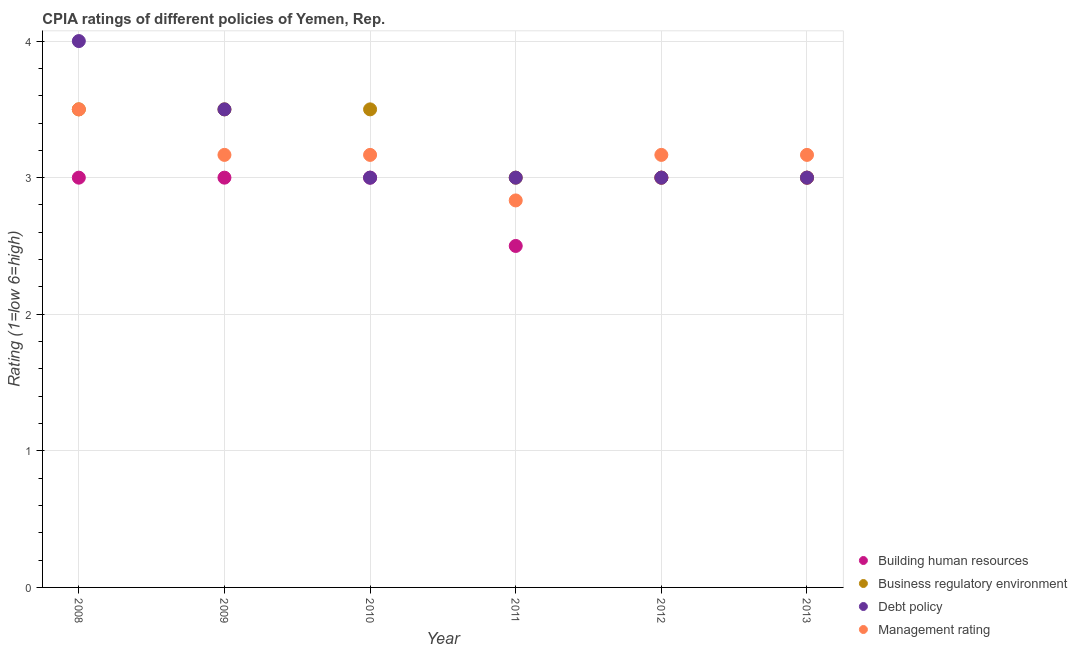In which year was the cpia rating of business regulatory environment maximum?
Your answer should be very brief. 2008. What is the difference between the cpia rating of debt policy in 2008 and the cpia rating of management in 2009?
Offer a very short reply. 0.83. What is the average cpia rating of building human resources per year?
Provide a succinct answer. 2.92. What is the ratio of the cpia rating of business regulatory environment in 2009 to that in 2011?
Give a very brief answer. 1.17. Is the difference between the cpia rating of building human resources in 2009 and 2011 greater than the difference between the cpia rating of management in 2009 and 2011?
Offer a terse response. Yes. What is the difference between the highest and the lowest cpia rating of building human resources?
Give a very brief answer. 0.5. In how many years, is the cpia rating of management greater than the average cpia rating of management taken over all years?
Keep it short and to the point. 5. Is the sum of the cpia rating of management in 2012 and 2013 greater than the maximum cpia rating of debt policy across all years?
Make the answer very short. Yes. Is it the case that in every year, the sum of the cpia rating of building human resources and cpia rating of business regulatory environment is greater than the cpia rating of debt policy?
Keep it short and to the point. Yes. Does the cpia rating of debt policy monotonically increase over the years?
Keep it short and to the point. No. Is the cpia rating of debt policy strictly greater than the cpia rating of management over the years?
Make the answer very short. No. Is the cpia rating of building human resources strictly less than the cpia rating of business regulatory environment over the years?
Offer a very short reply. No. How many years are there in the graph?
Keep it short and to the point. 6. What is the difference between two consecutive major ticks on the Y-axis?
Your response must be concise. 1. Where does the legend appear in the graph?
Make the answer very short. Bottom right. How many legend labels are there?
Your response must be concise. 4. How are the legend labels stacked?
Offer a very short reply. Vertical. What is the title of the graph?
Your response must be concise. CPIA ratings of different policies of Yemen, Rep. Does "Bird species" appear as one of the legend labels in the graph?
Offer a terse response. No. What is the label or title of the X-axis?
Keep it short and to the point. Year. What is the Rating (1=low 6=high) in Building human resources in 2008?
Your response must be concise. 3. What is the Rating (1=low 6=high) of Debt policy in 2008?
Your answer should be compact. 4. What is the Rating (1=low 6=high) in Management rating in 2008?
Your response must be concise. 3.5. What is the Rating (1=low 6=high) in Building human resources in 2009?
Make the answer very short. 3. What is the Rating (1=low 6=high) in Business regulatory environment in 2009?
Offer a very short reply. 3.5. What is the Rating (1=low 6=high) in Debt policy in 2009?
Provide a short and direct response. 3.5. What is the Rating (1=low 6=high) in Management rating in 2009?
Provide a succinct answer. 3.17. What is the Rating (1=low 6=high) in Business regulatory environment in 2010?
Provide a short and direct response. 3.5. What is the Rating (1=low 6=high) of Debt policy in 2010?
Your response must be concise. 3. What is the Rating (1=low 6=high) of Management rating in 2010?
Keep it short and to the point. 3.17. What is the Rating (1=low 6=high) of Business regulatory environment in 2011?
Your answer should be compact. 3. What is the Rating (1=low 6=high) of Debt policy in 2011?
Your answer should be compact. 3. What is the Rating (1=low 6=high) in Management rating in 2011?
Your answer should be very brief. 2.83. What is the Rating (1=low 6=high) of Debt policy in 2012?
Provide a short and direct response. 3. What is the Rating (1=low 6=high) in Management rating in 2012?
Provide a short and direct response. 3.17. What is the Rating (1=low 6=high) in Building human resources in 2013?
Keep it short and to the point. 3. What is the Rating (1=low 6=high) in Management rating in 2013?
Your answer should be very brief. 3.17. Across all years, what is the maximum Rating (1=low 6=high) of Building human resources?
Keep it short and to the point. 3. Across all years, what is the maximum Rating (1=low 6=high) of Management rating?
Provide a succinct answer. 3.5. Across all years, what is the minimum Rating (1=low 6=high) of Business regulatory environment?
Give a very brief answer. 3. Across all years, what is the minimum Rating (1=low 6=high) in Debt policy?
Give a very brief answer. 3. Across all years, what is the minimum Rating (1=low 6=high) of Management rating?
Your answer should be very brief. 2.83. What is the difference between the Rating (1=low 6=high) in Building human resources in 2008 and that in 2009?
Offer a terse response. 0. What is the difference between the Rating (1=low 6=high) of Business regulatory environment in 2008 and that in 2009?
Offer a terse response. 0. What is the difference between the Rating (1=low 6=high) in Debt policy in 2008 and that in 2009?
Your response must be concise. 0.5. What is the difference between the Rating (1=low 6=high) of Management rating in 2008 and that in 2009?
Provide a short and direct response. 0.33. What is the difference between the Rating (1=low 6=high) of Building human resources in 2008 and that in 2010?
Give a very brief answer. 0. What is the difference between the Rating (1=low 6=high) in Debt policy in 2008 and that in 2010?
Offer a terse response. 1. What is the difference between the Rating (1=low 6=high) of Management rating in 2008 and that in 2010?
Keep it short and to the point. 0.33. What is the difference between the Rating (1=low 6=high) of Building human resources in 2008 and that in 2011?
Make the answer very short. 0.5. What is the difference between the Rating (1=low 6=high) in Debt policy in 2008 and that in 2011?
Your response must be concise. 1. What is the difference between the Rating (1=low 6=high) of Management rating in 2008 and that in 2011?
Ensure brevity in your answer.  0.67. What is the difference between the Rating (1=low 6=high) in Building human resources in 2008 and that in 2012?
Keep it short and to the point. 0. What is the difference between the Rating (1=low 6=high) in Debt policy in 2008 and that in 2012?
Your response must be concise. 1. What is the difference between the Rating (1=low 6=high) of Building human resources in 2008 and that in 2013?
Your answer should be very brief. 0. What is the difference between the Rating (1=low 6=high) of Business regulatory environment in 2008 and that in 2013?
Keep it short and to the point. 0.5. What is the difference between the Rating (1=low 6=high) of Management rating in 2008 and that in 2013?
Offer a terse response. 0.33. What is the difference between the Rating (1=low 6=high) in Business regulatory environment in 2009 and that in 2010?
Keep it short and to the point. 0. What is the difference between the Rating (1=low 6=high) of Debt policy in 2009 and that in 2010?
Provide a short and direct response. 0.5. What is the difference between the Rating (1=low 6=high) of Building human resources in 2009 and that in 2011?
Offer a terse response. 0.5. What is the difference between the Rating (1=low 6=high) of Business regulatory environment in 2009 and that in 2011?
Your answer should be compact. 0.5. What is the difference between the Rating (1=low 6=high) in Debt policy in 2009 and that in 2011?
Your response must be concise. 0.5. What is the difference between the Rating (1=low 6=high) in Building human resources in 2009 and that in 2012?
Make the answer very short. 0. What is the difference between the Rating (1=low 6=high) of Business regulatory environment in 2009 and that in 2012?
Provide a succinct answer. 0.5. What is the difference between the Rating (1=low 6=high) of Business regulatory environment in 2009 and that in 2013?
Make the answer very short. 0.5. What is the difference between the Rating (1=low 6=high) in Building human resources in 2010 and that in 2011?
Provide a succinct answer. 0.5. What is the difference between the Rating (1=low 6=high) of Business regulatory environment in 2010 and that in 2011?
Make the answer very short. 0.5. What is the difference between the Rating (1=low 6=high) in Management rating in 2010 and that in 2011?
Provide a short and direct response. 0.33. What is the difference between the Rating (1=low 6=high) of Building human resources in 2010 and that in 2012?
Your answer should be very brief. 0. What is the difference between the Rating (1=low 6=high) of Debt policy in 2010 and that in 2012?
Your answer should be very brief. 0. What is the difference between the Rating (1=low 6=high) in Debt policy in 2010 and that in 2013?
Your answer should be very brief. 0. What is the difference between the Rating (1=low 6=high) of Business regulatory environment in 2011 and that in 2012?
Your answer should be compact. 0. What is the difference between the Rating (1=low 6=high) in Management rating in 2011 and that in 2012?
Offer a terse response. -0.33. What is the difference between the Rating (1=low 6=high) of Building human resources in 2011 and that in 2013?
Give a very brief answer. -0.5. What is the difference between the Rating (1=low 6=high) in Building human resources in 2012 and that in 2013?
Provide a short and direct response. 0. What is the difference between the Rating (1=low 6=high) in Business regulatory environment in 2012 and that in 2013?
Your answer should be very brief. 0. What is the difference between the Rating (1=low 6=high) in Management rating in 2012 and that in 2013?
Keep it short and to the point. 0. What is the difference between the Rating (1=low 6=high) of Building human resources in 2008 and the Rating (1=low 6=high) of Business regulatory environment in 2009?
Give a very brief answer. -0.5. What is the difference between the Rating (1=low 6=high) of Building human resources in 2008 and the Rating (1=low 6=high) of Management rating in 2009?
Your answer should be compact. -0.17. What is the difference between the Rating (1=low 6=high) in Business regulatory environment in 2008 and the Rating (1=low 6=high) in Debt policy in 2009?
Ensure brevity in your answer.  0. What is the difference between the Rating (1=low 6=high) in Business regulatory environment in 2008 and the Rating (1=low 6=high) in Management rating in 2009?
Offer a terse response. 0.33. What is the difference between the Rating (1=low 6=high) of Building human resources in 2008 and the Rating (1=low 6=high) of Business regulatory environment in 2010?
Offer a terse response. -0.5. What is the difference between the Rating (1=low 6=high) in Building human resources in 2008 and the Rating (1=low 6=high) in Debt policy in 2010?
Make the answer very short. 0. What is the difference between the Rating (1=low 6=high) of Debt policy in 2008 and the Rating (1=low 6=high) of Management rating in 2010?
Ensure brevity in your answer.  0.83. What is the difference between the Rating (1=low 6=high) in Building human resources in 2008 and the Rating (1=low 6=high) in Debt policy in 2011?
Your answer should be compact. 0. What is the difference between the Rating (1=low 6=high) in Building human resources in 2008 and the Rating (1=low 6=high) in Management rating in 2011?
Your response must be concise. 0.17. What is the difference between the Rating (1=low 6=high) in Business regulatory environment in 2008 and the Rating (1=low 6=high) in Debt policy in 2011?
Your answer should be compact. 0.5. What is the difference between the Rating (1=low 6=high) of Business regulatory environment in 2008 and the Rating (1=low 6=high) of Management rating in 2011?
Your answer should be very brief. 0.67. What is the difference between the Rating (1=low 6=high) of Building human resources in 2008 and the Rating (1=low 6=high) of Management rating in 2012?
Offer a terse response. -0.17. What is the difference between the Rating (1=low 6=high) in Debt policy in 2008 and the Rating (1=low 6=high) in Management rating in 2012?
Ensure brevity in your answer.  0.83. What is the difference between the Rating (1=low 6=high) in Building human resources in 2008 and the Rating (1=low 6=high) in Business regulatory environment in 2013?
Your answer should be compact. 0. What is the difference between the Rating (1=low 6=high) in Building human resources in 2008 and the Rating (1=low 6=high) in Management rating in 2013?
Give a very brief answer. -0.17. What is the difference between the Rating (1=low 6=high) of Business regulatory environment in 2008 and the Rating (1=low 6=high) of Debt policy in 2013?
Your answer should be compact. 0.5. What is the difference between the Rating (1=low 6=high) of Business regulatory environment in 2008 and the Rating (1=low 6=high) of Management rating in 2013?
Your answer should be compact. 0.33. What is the difference between the Rating (1=low 6=high) of Debt policy in 2008 and the Rating (1=low 6=high) of Management rating in 2013?
Ensure brevity in your answer.  0.83. What is the difference between the Rating (1=low 6=high) of Business regulatory environment in 2009 and the Rating (1=low 6=high) of Debt policy in 2010?
Give a very brief answer. 0.5. What is the difference between the Rating (1=low 6=high) in Business regulatory environment in 2009 and the Rating (1=low 6=high) in Management rating in 2010?
Ensure brevity in your answer.  0.33. What is the difference between the Rating (1=low 6=high) of Debt policy in 2009 and the Rating (1=low 6=high) of Management rating in 2011?
Your answer should be very brief. 0.67. What is the difference between the Rating (1=low 6=high) of Building human resources in 2009 and the Rating (1=low 6=high) of Management rating in 2012?
Provide a short and direct response. -0.17. What is the difference between the Rating (1=low 6=high) in Business regulatory environment in 2009 and the Rating (1=low 6=high) in Management rating in 2012?
Your response must be concise. 0.33. What is the difference between the Rating (1=low 6=high) of Debt policy in 2009 and the Rating (1=low 6=high) of Management rating in 2012?
Your answer should be very brief. 0.33. What is the difference between the Rating (1=low 6=high) in Building human resources in 2009 and the Rating (1=low 6=high) in Business regulatory environment in 2013?
Keep it short and to the point. 0. What is the difference between the Rating (1=low 6=high) of Building human resources in 2009 and the Rating (1=low 6=high) of Management rating in 2013?
Keep it short and to the point. -0.17. What is the difference between the Rating (1=low 6=high) of Business regulatory environment in 2009 and the Rating (1=low 6=high) of Debt policy in 2013?
Give a very brief answer. 0.5. What is the difference between the Rating (1=low 6=high) in Debt policy in 2009 and the Rating (1=low 6=high) in Management rating in 2013?
Make the answer very short. 0.33. What is the difference between the Rating (1=low 6=high) of Building human resources in 2010 and the Rating (1=low 6=high) of Business regulatory environment in 2011?
Your response must be concise. 0. What is the difference between the Rating (1=low 6=high) of Building human resources in 2010 and the Rating (1=low 6=high) of Debt policy in 2011?
Your answer should be very brief. 0. What is the difference between the Rating (1=low 6=high) in Building human resources in 2010 and the Rating (1=low 6=high) in Management rating in 2011?
Provide a short and direct response. 0.17. What is the difference between the Rating (1=low 6=high) in Business regulatory environment in 2010 and the Rating (1=low 6=high) in Debt policy in 2011?
Offer a very short reply. 0.5. What is the difference between the Rating (1=low 6=high) in Debt policy in 2010 and the Rating (1=low 6=high) in Management rating in 2012?
Ensure brevity in your answer.  -0.17. What is the difference between the Rating (1=low 6=high) of Building human resources in 2010 and the Rating (1=low 6=high) of Debt policy in 2013?
Give a very brief answer. 0. What is the difference between the Rating (1=low 6=high) of Building human resources in 2010 and the Rating (1=low 6=high) of Management rating in 2013?
Your answer should be compact. -0.17. What is the difference between the Rating (1=low 6=high) in Business regulatory environment in 2010 and the Rating (1=low 6=high) in Management rating in 2013?
Give a very brief answer. 0.33. What is the difference between the Rating (1=low 6=high) in Debt policy in 2010 and the Rating (1=low 6=high) in Management rating in 2013?
Ensure brevity in your answer.  -0.17. What is the difference between the Rating (1=low 6=high) of Building human resources in 2011 and the Rating (1=low 6=high) of Business regulatory environment in 2012?
Keep it short and to the point. -0.5. What is the difference between the Rating (1=low 6=high) in Business regulatory environment in 2011 and the Rating (1=low 6=high) in Debt policy in 2012?
Offer a very short reply. 0. What is the difference between the Rating (1=low 6=high) of Building human resources in 2011 and the Rating (1=low 6=high) of Business regulatory environment in 2013?
Offer a terse response. -0.5. What is the difference between the Rating (1=low 6=high) of Business regulatory environment in 2011 and the Rating (1=low 6=high) of Management rating in 2013?
Offer a terse response. -0.17. What is the difference between the Rating (1=low 6=high) of Debt policy in 2011 and the Rating (1=low 6=high) of Management rating in 2013?
Your answer should be compact. -0.17. What is the difference between the Rating (1=low 6=high) in Building human resources in 2012 and the Rating (1=low 6=high) in Management rating in 2013?
Your answer should be compact. -0.17. What is the average Rating (1=low 6=high) of Building human resources per year?
Provide a succinct answer. 2.92. What is the average Rating (1=low 6=high) in Business regulatory environment per year?
Your answer should be compact. 3.25. What is the average Rating (1=low 6=high) of Management rating per year?
Provide a succinct answer. 3.17. In the year 2008, what is the difference between the Rating (1=low 6=high) in Building human resources and Rating (1=low 6=high) in Business regulatory environment?
Offer a very short reply. -0.5. In the year 2008, what is the difference between the Rating (1=low 6=high) of Business regulatory environment and Rating (1=low 6=high) of Debt policy?
Your answer should be compact. -0.5. In the year 2008, what is the difference between the Rating (1=low 6=high) of Debt policy and Rating (1=low 6=high) of Management rating?
Your answer should be compact. 0.5. In the year 2009, what is the difference between the Rating (1=low 6=high) of Building human resources and Rating (1=low 6=high) of Business regulatory environment?
Provide a succinct answer. -0.5. In the year 2009, what is the difference between the Rating (1=low 6=high) in Building human resources and Rating (1=low 6=high) in Debt policy?
Offer a very short reply. -0.5. In the year 2009, what is the difference between the Rating (1=low 6=high) in Business regulatory environment and Rating (1=low 6=high) in Debt policy?
Ensure brevity in your answer.  0. In the year 2010, what is the difference between the Rating (1=low 6=high) in Building human resources and Rating (1=low 6=high) in Business regulatory environment?
Your response must be concise. -0.5. In the year 2010, what is the difference between the Rating (1=low 6=high) in Building human resources and Rating (1=low 6=high) in Debt policy?
Provide a short and direct response. 0. In the year 2010, what is the difference between the Rating (1=low 6=high) in Business regulatory environment and Rating (1=low 6=high) in Debt policy?
Provide a succinct answer. 0.5. In the year 2010, what is the difference between the Rating (1=low 6=high) in Debt policy and Rating (1=low 6=high) in Management rating?
Your answer should be very brief. -0.17. In the year 2011, what is the difference between the Rating (1=low 6=high) in Building human resources and Rating (1=low 6=high) in Business regulatory environment?
Your response must be concise. -0.5. In the year 2011, what is the difference between the Rating (1=low 6=high) in Building human resources and Rating (1=low 6=high) in Debt policy?
Provide a short and direct response. -0.5. In the year 2011, what is the difference between the Rating (1=low 6=high) of Building human resources and Rating (1=low 6=high) of Management rating?
Your response must be concise. -0.33. In the year 2011, what is the difference between the Rating (1=low 6=high) in Business regulatory environment and Rating (1=low 6=high) in Management rating?
Your answer should be very brief. 0.17. In the year 2012, what is the difference between the Rating (1=low 6=high) in Building human resources and Rating (1=low 6=high) in Management rating?
Ensure brevity in your answer.  -0.17. In the year 2012, what is the difference between the Rating (1=low 6=high) in Business regulatory environment and Rating (1=low 6=high) in Management rating?
Offer a terse response. -0.17. In the year 2012, what is the difference between the Rating (1=low 6=high) in Debt policy and Rating (1=low 6=high) in Management rating?
Offer a terse response. -0.17. In the year 2013, what is the difference between the Rating (1=low 6=high) of Building human resources and Rating (1=low 6=high) of Business regulatory environment?
Provide a succinct answer. 0. In the year 2013, what is the difference between the Rating (1=low 6=high) of Building human resources and Rating (1=low 6=high) of Management rating?
Provide a short and direct response. -0.17. In the year 2013, what is the difference between the Rating (1=low 6=high) of Business regulatory environment and Rating (1=low 6=high) of Debt policy?
Keep it short and to the point. 0. In the year 2013, what is the difference between the Rating (1=low 6=high) of Business regulatory environment and Rating (1=low 6=high) of Management rating?
Keep it short and to the point. -0.17. What is the ratio of the Rating (1=low 6=high) in Building human resources in 2008 to that in 2009?
Ensure brevity in your answer.  1. What is the ratio of the Rating (1=low 6=high) of Management rating in 2008 to that in 2009?
Ensure brevity in your answer.  1.11. What is the ratio of the Rating (1=low 6=high) of Debt policy in 2008 to that in 2010?
Give a very brief answer. 1.33. What is the ratio of the Rating (1=low 6=high) of Management rating in 2008 to that in 2010?
Keep it short and to the point. 1.11. What is the ratio of the Rating (1=low 6=high) in Debt policy in 2008 to that in 2011?
Make the answer very short. 1.33. What is the ratio of the Rating (1=low 6=high) of Management rating in 2008 to that in 2011?
Ensure brevity in your answer.  1.24. What is the ratio of the Rating (1=low 6=high) of Building human resources in 2008 to that in 2012?
Your response must be concise. 1. What is the ratio of the Rating (1=low 6=high) of Business regulatory environment in 2008 to that in 2012?
Provide a succinct answer. 1.17. What is the ratio of the Rating (1=low 6=high) of Management rating in 2008 to that in 2012?
Give a very brief answer. 1.11. What is the ratio of the Rating (1=low 6=high) in Business regulatory environment in 2008 to that in 2013?
Provide a short and direct response. 1.17. What is the ratio of the Rating (1=low 6=high) of Debt policy in 2008 to that in 2013?
Provide a short and direct response. 1.33. What is the ratio of the Rating (1=low 6=high) of Management rating in 2008 to that in 2013?
Offer a terse response. 1.11. What is the ratio of the Rating (1=low 6=high) in Debt policy in 2009 to that in 2010?
Your response must be concise. 1.17. What is the ratio of the Rating (1=low 6=high) in Building human resources in 2009 to that in 2011?
Your answer should be compact. 1.2. What is the ratio of the Rating (1=low 6=high) of Management rating in 2009 to that in 2011?
Ensure brevity in your answer.  1.12. What is the ratio of the Rating (1=low 6=high) in Building human resources in 2009 to that in 2012?
Offer a very short reply. 1. What is the ratio of the Rating (1=low 6=high) in Business regulatory environment in 2009 to that in 2012?
Your response must be concise. 1.17. What is the ratio of the Rating (1=low 6=high) in Management rating in 2009 to that in 2012?
Make the answer very short. 1. What is the ratio of the Rating (1=low 6=high) of Debt policy in 2009 to that in 2013?
Keep it short and to the point. 1.17. What is the ratio of the Rating (1=low 6=high) in Building human resources in 2010 to that in 2011?
Provide a succinct answer. 1.2. What is the ratio of the Rating (1=low 6=high) in Management rating in 2010 to that in 2011?
Your response must be concise. 1.12. What is the ratio of the Rating (1=low 6=high) of Debt policy in 2010 to that in 2012?
Make the answer very short. 1. What is the ratio of the Rating (1=low 6=high) of Business regulatory environment in 2010 to that in 2013?
Ensure brevity in your answer.  1.17. What is the ratio of the Rating (1=low 6=high) in Debt policy in 2010 to that in 2013?
Make the answer very short. 1. What is the ratio of the Rating (1=low 6=high) in Management rating in 2010 to that in 2013?
Offer a very short reply. 1. What is the ratio of the Rating (1=low 6=high) of Debt policy in 2011 to that in 2012?
Your response must be concise. 1. What is the ratio of the Rating (1=low 6=high) in Management rating in 2011 to that in 2012?
Keep it short and to the point. 0.89. What is the ratio of the Rating (1=low 6=high) in Business regulatory environment in 2011 to that in 2013?
Provide a succinct answer. 1. What is the ratio of the Rating (1=low 6=high) of Debt policy in 2011 to that in 2013?
Your response must be concise. 1. What is the ratio of the Rating (1=low 6=high) of Management rating in 2011 to that in 2013?
Provide a succinct answer. 0.89. What is the difference between the highest and the second highest Rating (1=low 6=high) of Building human resources?
Offer a terse response. 0. What is the difference between the highest and the second highest Rating (1=low 6=high) of Business regulatory environment?
Offer a very short reply. 0. What is the difference between the highest and the second highest Rating (1=low 6=high) in Debt policy?
Make the answer very short. 0.5. What is the difference between the highest and the lowest Rating (1=low 6=high) in Business regulatory environment?
Offer a terse response. 0.5. 